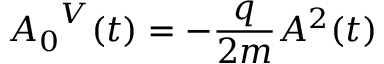Convert formula to latex. <formula><loc_0><loc_0><loc_500><loc_500>{ A _ { 0 } } ^ { V } ( t ) = - \frac { q } { 2 m } A ^ { 2 } ( t )</formula> 